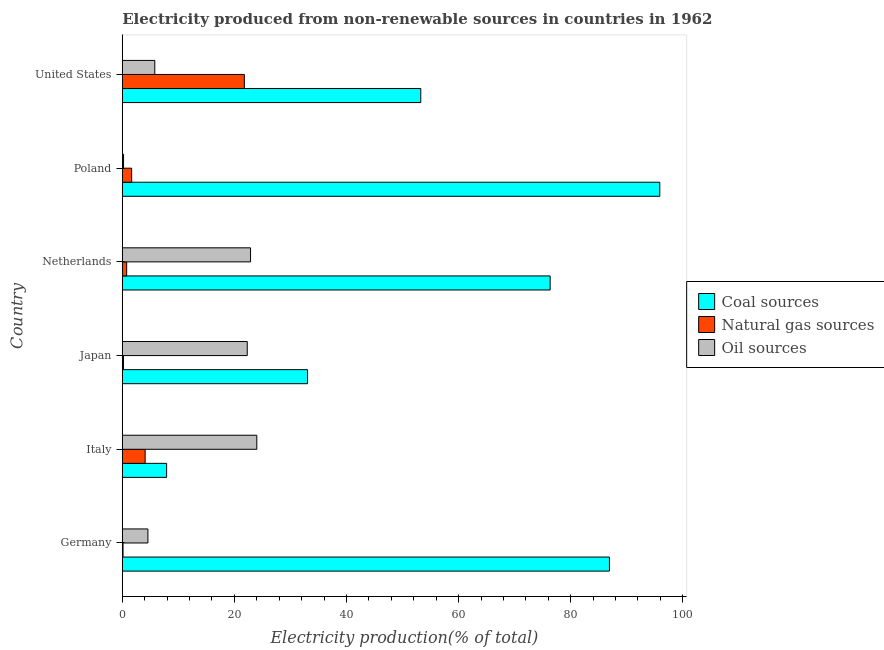Are the number of bars per tick equal to the number of legend labels?
Make the answer very short. Yes. Are the number of bars on each tick of the Y-axis equal?
Your answer should be very brief. Yes. What is the label of the 5th group of bars from the top?
Offer a terse response. Italy. In how many cases, is the number of bars for a given country not equal to the number of legend labels?
Ensure brevity in your answer.  0. What is the percentage of electricity produced by coal in Poland?
Your answer should be very brief. 95.89. Across all countries, what is the maximum percentage of electricity produced by oil sources?
Keep it short and to the point. 24. Across all countries, what is the minimum percentage of electricity produced by oil sources?
Your answer should be compact. 0.23. In which country was the percentage of electricity produced by coal minimum?
Make the answer very short. Italy. What is the total percentage of electricity produced by natural gas in the graph?
Ensure brevity in your answer.  28.66. What is the difference between the percentage of electricity produced by natural gas in Italy and that in Poland?
Your answer should be very brief. 2.41. What is the difference between the percentage of electricity produced by coal in United States and the percentage of electricity produced by oil sources in Italy?
Offer a very short reply. 29.25. What is the average percentage of electricity produced by oil sources per country?
Provide a succinct answer. 13.3. What is the difference between the percentage of electricity produced by natural gas and percentage of electricity produced by coal in Italy?
Offer a terse response. -3.83. What is the ratio of the percentage of electricity produced by coal in Germany to that in Poland?
Your response must be concise. 0.91. Is the percentage of electricity produced by coal in Germany less than that in Japan?
Make the answer very short. No. What is the difference between the highest and the second highest percentage of electricity produced by oil sources?
Offer a very short reply. 1.12. What is the difference between the highest and the lowest percentage of electricity produced by natural gas?
Keep it short and to the point. 21.64. What does the 1st bar from the top in Poland represents?
Provide a short and direct response. Oil sources. What does the 2nd bar from the bottom in Poland represents?
Offer a terse response. Natural gas sources. Is it the case that in every country, the sum of the percentage of electricity produced by coal and percentage of electricity produced by natural gas is greater than the percentage of electricity produced by oil sources?
Keep it short and to the point. No. How many countries are there in the graph?
Ensure brevity in your answer.  6. Are the values on the major ticks of X-axis written in scientific E-notation?
Offer a very short reply. No. Does the graph contain any zero values?
Your answer should be very brief. No. Where does the legend appear in the graph?
Your answer should be compact. Center right. What is the title of the graph?
Offer a very short reply. Electricity produced from non-renewable sources in countries in 1962. Does "Ages 20-60" appear as one of the legend labels in the graph?
Your answer should be very brief. No. What is the label or title of the X-axis?
Provide a short and direct response. Electricity production(% of total). What is the Electricity production(% of total) of Coal sources in Germany?
Offer a very short reply. 86.91. What is the Electricity production(% of total) in Natural gas sources in Germany?
Your response must be concise. 0.14. What is the Electricity production(% of total) in Oil sources in Germany?
Keep it short and to the point. 4.57. What is the Electricity production(% of total) of Coal sources in Italy?
Give a very brief answer. 7.91. What is the Electricity production(% of total) in Natural gas sources in Italy?
Offer a very short reply. 4.08. What is the Electricity production(% of total) of Oil sources in Italy?
Provide a succinct answer. 24. What is the Electricity production(% of total) in Coal sources in Japan?
Provide a short and direct response. 33.05. What is the Electricity production(% of total) in Natural gas sources in Japan?
Ensure brevity in your answer.  0.21. What is the Electricity production(% of total) in Oil sources in Japan?
Provide a short and direct response. 22.29. What is the Electricity production(% of total) in Coal sources in Netherlands?
Offer a very short reply. 76.33. What is the Electricity production(% of total) in Natural gas sources in Netherlands?
Your answer should be very brief. 0.78. What is the Electricity production(% of total) in Oil sources in Netherlands?
Offer a terse response. 22.88. What is the Electricity production(% of total) in Coal sources in Poland?
Your response must be concise. 95.89. What is the Electricity production(% of total) of Natural gas sources in Poland?
Keep it short and to the point. 1.67. What is the Electricity production(% of total) of Oil sources in Poland?
Make the answer very short. 0.23. What is the Electricity production(% of total) in Coal sources in United States?
Your answer should be compact. 53.25. What is the Electricity production(% of total) in Natural gas sources in United States?
Provide a short and direct response. 21.78. What is the Electricity production(% of total) in Oil sources in United States?
Your answer should be very brief. 5.8. Across all countries, what is the maximum Electricity production(% of total) of Coal sources?
Your answer should be compact. 95.89. Across all countries, what is the maximum Electricity production(% of total) of Natural gas sources?
Offer a very short reply. 21.78. Across all countries, what is the maximum Electricity production(% of total) in Oil sources?
Ensure brevity in your answer.  24. Across all countries, what is the minimum Electricity production(% of total) of Coal sources?
Your response must be concise. 7.91. Across all countries, what is the minimum Electricity production(% of total) in Natural gas sources?
Ensure brevity in your answer.  0.14. Across all countries, what is the minimum Electricity production(% of total) in Oil sources?
Provide a short and direct response. 0.23. What is the total Electricity production(% of total) in Coal sources in the graph?
Offer a terse response. 353.34. What is the total Electricity production(% of total) of Natural gas sources in the graph?
Your answer should be very brief. 28.66. What is the total Electricity production(% of total) in Oil sources in the graph?
Your response must be concise. 79.77. What is the difference between the Electricity production(% of total) of Coal sources in Germany and that in Italy?
Your answer should be very brief. 79. What is the difference between the Electricity production(% of total) in Natural gas sources in Germany and that in Italy?
Your response must be concise. -3.94. What is the difference between the Electricity production(% of total) in Oil sources in Germany and that in Italy?
Ensure brevity in your answer.  -19.43. What is the difference between the Electricity production(% of total) of Coal sources in Germany and that in Japan?
Your response must be concise. 53.86. What is the difference between the Electricity production(% of total) of Natural gas sources in Germany and that in Japan?
Provide a succinct answer. -0.08. What is the difference between the Electricity production(% of total) of Oil sources in Germany and that in Japan?
Provide a succinct answer. -17.72. What is the difference between the Electricity production(% of total) in Coal sources in Germany and that in Netherlands?
Offer a terse response. 10.58. What is the difference between the Electricity production(% of total) of Natural gas sources in Germany and that in Netherlands?
Offer a terse response. -0.65. What is the difference between the Electricity production(% of total) in Oil sources in Germany and that in Netherlands?
Keep it short and to the point. -18.31. What is the difference between the Electricity production(% of total) in Coal sources in Germany and that in Poland?
Provide a succinct answer. -8.98. What is the difference between the Electricity production(% of total) in Natural gas sources in Germany and that in Poland?
Provide a succinct answer. -1.53. What is the difference between the Electricity production(% of total) of Oil sources in Germany and that in Poland?
Your response must be concise. 4.35. What is the difference between the Electricity production(% of total) of Coal sources in Germany and that in United States?
Your answer should be very brief. 33.66. What is the difference between the Electricity production(% of total) in Natural gas sources in Germany and that in United States?
Offer a terse response. -21.64. What is the difference between the Electricity production(% of total) in Oil sources in Germany and that in United States?
Provide a short and direct response. -1.23. What is the difference between the Electricity production(% of total) in Coal sources in Italy and that in Japan?
Ensure brevity in your answer.  -25.14. What is the difference between the Electricity production(% of total) of Natural gas sources in Italy and that in Japan?
Provide a short and direct response. 3.86. What is the difference between the Electricity production(% of total) in Oil sources in Italy and that in Japan?
Your answer should be compact. 1.71. What is the difference between the Electricity production(% of total) in Coal sources in Italy and that in Netherlands?
Your answer should be very brief. -68.42. What is the difference between the Electricity production(% of total) of Natural gas sources in Italy and that in Netherlands?
Give a very brief answer. 3.29. What is the difference between the Electricity production(% of total) in Oil sources in Italy and that in Netherlands?
Provide a succinct answer. 1.12. What is the difference between the Electricity production(% of total) of Coal sources in Italy and that in Poland?
Make the answer very short. -87.98. What is the difference between the Electricity production(% of total) of Natural gas sources in Italy and that in Poland?
Ensure brevity in your answer.  2.41. What is the difference between the Electricity production(% of total) of Oil sources in Italy and that in Poland?
Give a very brief answer. 23.77. What is the difference between the Electricity production(% of total) in Coal sources in Italy and that in United States?
Your answer should be compact. -45.34. What is the difference between the Electricity production(% of total) of Natural gas sources in Italy and that in United States?
Provide a short and direct response. -17.7. What is the difference between the Electricity production(% of total) in Oil sources in Italy and that in United States?
Ensure brevity in your answer.  18.2. What is the difference between the Electricity production(% of total) in Coal sources in Japan and that in Netherlands?
Your response must be concise. -43.28. What is the difference between the Electricity production(% of total) in Natural gas sources in Japan and that in Netherlands?
Your response must be concise. -0.57. What is the difference between the Electricity production(% of total) in Oil sources in Japan and that in Netherlands?
Keep it short and to the point. -0.59. What is the difference between the Electricity production(% of total) of Coal sources in Japan and that in Poland?
Your response must be concise. -62.84. What is the difference between the Electricity production(% of total) in Natural gas sources in Japan and that in Poland?
Keep it short and to the point. -1.46. What is the difference between the Electricity production(% of total) of Oil sources in Japan and that in Poland?
Make the answer very short. 22.07. What is the difference between the Electricity production(% of total) of Coal sources in Japan and that in United States?
Your answer should be very brief. -20.2. What is the difference between the Electricity production(% of total) of Natural gas sources in Japan and that in United States?
Offer a very short reply. -21.56. What is the difference between the Electricity production(% of total) of Oil sources in Japan and that in United States?
Keep it short and to the point. 16.49. What is the difference between the Electricity production(% of total) of Coal sources in Netherlands and that in Poland?
Offer a terse response. -19.56. What is the difference between the Electricity production(% of total) in Natural gas sources in Netherlands and that in Poland?
Your answer should be very brief. -0.89. What is the difference between the Electricity production(% of total) of Oil sources in Netherlands and that in Poland?
Give a very brief answer. 22.66. What is the difference between the Electricity production(% of total) in Coal sources in Netherlands and that in United States?
Your answer should be compact. 23.08. What is the difference between the Electricity production(% of total) of Natural gas sources in Netherlands and that in United States?
Your response must be concise. -20.99. What is the difference between the Electricity production(% of total) of Oil sources in Netherlands and that in United States?
Make the answer very short. 17.08. What is the difference between the Electricity production(% of total) of Coal sources in Poland and that in United States?
Give a very brief answer. 42.64. What is the difference between the Electricity production(% of total) in Natural gas sources in Poland and that in United States?
Provide a succinct answer. -20.11. What is the difference between the Electricity production(% of total) of Oil sources in Poland and that in United States?
Provide a short and direct response. -5.57. What is the difference between the Electricity production(% of total) of Coal sources in Germany and the Electricity production(% of total) of Natural gas sources in Italy?
Your answer should be very brief. 82.83. What is the difference between the Electricity production(% of total) in Coal sources in Germany and the Electricity production(% of total) in Oil sources in Italy?
Your response must be concise. 62.91. What is the difference between the Electricity production(% of total) in Natural gas sources in Germany and the Electricity production(% of total) in Oil sources in Italy?
Your answer should be very brief. -23.86. What is the difference between the Electricity production(% of total) of Coal sources in Germany and the Electricity production(% of total) of Natural gas sources in Japan?
Ensure brevity in your answer.  86.7. What is the difference between the Electricity production(% of total) in Coal sources in Germany and the Electricity production(% of total) in Oil sources in Japan?
Offer a terse response. 64.62. What is the difference between the Electricity production(% of total) in Natural gas sources in Germany and the Electricity production(% of total) in Oil sources in Japan?
Your answer should be very brief. -22.16. What is the difference between the Electricity production(% of total) of Coal sources in Germany and the Electricity production(% of total) of Natural gas sources in Netherlands?
Offer a terse response. 86.12. What is the difference between the Electricity production(% of total) in Coal sources in Germany and the Electricity production(% of total) in Oil sources in Netherlands?
Offer a terse response. 64.03. What is the difference between the Electricity production(% of total) in Natural gas sources in Germany and the Electricity production(% of total) in Oil sources in Netherlands?
Provide a short and direct response. -22.75. What is the difference between the Electricity production(% of total) in Coal sources in Germany and the Electricity production(% of total) in Natural gas sources in Poland?
Your answer should be very brief. 85.24. What is the difference between the Electricity production(% of total) of Coal sources in Germany and the Electricity production(% of total) of Oil sources in Poland?
Your response must be concise. 86.68. What is the difference between the Electricity production(% of total) in Natural gas sources in Germany and the Electricity production(% of total) in Oil sources in Poland?
Give a very brief answer. -0.09. What is the difference between the Electricity production(% of total) in Coal sources in Germany and the Electricity production(% of total) in Natural gas sources in United States?
Provide a short and direct response. 65.13. What is the difference between the Electricity production(% of total) in Coal sources in Germany and the Electricity production(% of total) in Oil sources in United States?
Give a very brief answer. 81.11. What is the difference between the Electricity production(% of total) in Natural gas sources in Germany and the Electricity production(% of total) in Oil sources in United States?
Provide a succinct answer. -5.66. What is the difference between the Electricity production(% of total) in Coal sources in Italy and the Electricity production(% of total) in Natural gas sources in Japan?
Keep it short and to the point. 7.7. What is the difference between the Electricity production(% of total) of Coal sources in Italy and the Electricity production(% of total) of Oil sources in Japan?
Your response must be concise. -14.38. What is the difference between the Electricity production(% of total) in Natural gas sources in Italy and the Electricity production(% of total) in Oil sources in Japan?
Make the answer very short. -18.21. What is the difference between the Electricity production(% of total) of Coal sources in Italy and the Electricity production(% of total) of Natural gas sources in Netherlands?
Offer a very short reply. 7.12. What is the difference between the Electricity production(% of total) of Coal sources in Italy and the Electricity production(% of total) of Oil sources in Netherlands?
Make the answer very short. -14.97. What is the difference between the Electricity production(% of total) of Natural gas sources in Italy and the Electricity production(% of total) of Oil sources in Netherlands?
Offer a terse response. -18.8. What is the difference between the Electricity production(% of total) of Coal sources in Italy and the Electricity production(% of total) of Natural gas sources in Poland?
Make the answer very short. 6.24. What is the difference between the Electricity production(% of total) in Coal sources in Italy and the Electricity production(% of total) in Oil sources in Poland?
Your answer should be compact. 7.68. What is the difference between the Electricity production(% of total) of Natural gas sources in Italy and the Electricity production(% of total) of Oil sources in Poland?
Your answer should be compact. 3.85. What is the difference between the Electricity production(% of total) of Coal sources in Italy and the Electricity production(% of total) of Natural gas sources in United States?
Ensure brevity in your answer.  -13.87. What is the difference between the Electricity production(% of total) of Coal sources in Italy and the Electricity production(% of total) of Oil sources in United States?
Provide a short and direct response. 2.11. What is the difference between the Electricity production(% of total) of Natural gas sources in Italy and the Electricity production(% of total) of Oil sources in United States?
Give a very brief answer. -1.72. What is the difference between the Electricity production(% of total) of Coal sources in Japan and the Electricity production(% of total) of Natural gas sources in Netherlands?
Provide a succinct answer. 32.26. What is the difference between the Electricity production(% of total) in Coal sources in Japan and the Electricity production(% of total) in Oil sources in Netherlands?
Your response must be concise. 10.17. What is the difference between the Electricity production(% of total) of Natural gas sources in Japan and the Electricity production(% of total) of Oil sources in Netherlands?
Offer a very short reply. -22.67. What is the difference between the Electricity production(% of total) in Coal sources in Japan and the Electricity production(% of total) in Natural gas sources in Poland?
Make the answer very short. 31.38. What is the difference between the Electricity production(% of total) in Coal sources in Japan and the Electricity production(% of total) in Oil sources in Poland?
Ensure brevity in your answer.  32.82. What is the difference between the Electricity production(% of total) of Natural gas sources in Japan and the Electricity production(% of total) of Oil sources in Poland?
Make the answer very short. -0.01. What is the difference between the Electricity production(% of total) in Coal sources in Japan and the Electricity production(% of total) in Natural gas sources in United States?
Your answer should be compact. 11.27. What is the difference between the Electricity production(% of total) of Coal sources in Japan and the Electricity production(% of total) of Oil sources in United States?
Keep it short and to the point. 27.25. What is the difference between the Electricity production(% of total) in Natural gas sources in Japan and the Electricity production(% of total) in Oil sources in United States?
Your response must be concise. -5.59. What is the difference between the Electricity production(% of total) in Coal sources in Netherlands and the Electricity production(% of total) in Natural gas sources in Poland?
Offer a terse response. 74.66. What is the difference between the Electricity production(% of total) of Coal sources in Netherlands and the Electricity production(% of total) of Oil sources in Poland?
Your answer should be compact. 76.11. What is the difference between the Electricity production(% of total) in Natural gas sources in Netherlands and the Electricity production(% of total) in Oil sources in Poland?
Keep it short and to the point. 0.56. What is the difference between the Electricity production(% of total) in Coal sources in Netherlands and the Electricity production(% of total) in Natural gas sources in United States?
Offer a terse response. 54.56. What is the difference between the Electricity production(% of total) in Coal sources in Netherlands and the Electricity production(% of total) in Oil sources in United States?
Make the answer very short. 70.53. What is the difference between the Electricity production(% of total) of Natural gas sources in Netherlands and the Electricity production(% of total) of Oil sources in United States?
Provide a short and direct response. -5.02. What is the difference between the Electricity production(% of total) in Coal sources in Poland and the Electricity production(% of total) in Natural gas sources in United States?
Keep it short and to the point. 74.11. What is the difference between the Electricity production(% of total) of Coal sources in Poland and the Electricity production(% of total) of Oil sources in United States?
Your answer should be compact. 90.09. What is the difference between the Electricity production(% of total) of Natural gas sources in Poland and the Electricity production(% of total) of Oil sources in United States?
Your answer should be compact. -4.13. What is the average Electricity production(% of total) of Coal sources per country?
Your response must be concise. 58.89. What is the average Electricity production(% of total) of Natural gas sources per country?
Provide a succinct answer. 4.78. What is the average Electricity production(% of total) of Oil sources per country?
Ensure brevity in your answer.  13.3. What is the difference between the Electricity production(% of total) in Coal sources and Electricity production(% of total) in Natural gas sources in Germany?
Your answer should be compact. 86.77. What is the difference between the Electricity production(% of total) in Coal sources and Electricity production(% of total) in Oil sources in Germany?
Your answer should be compact. 82.34. What is the difference between the Electricity production(% of total) of Natural gas sources and Electricity production(% of total) of Oil sources in Germany?
Make the answer very short. -4.44. What is the difference between the Electricity production(% of total) in Coal sources and Electricity production(% of total) in Natural gas sources in Italy?
Offer a terse response. 3.83. What is the difference between the Electricity production(% of total) of Coal sources and Electricity production(% of total) of Oil sources in Italy?
Your answer should be compact. -16.09. What is the difference between the Electricity production(% of total) in Natural gas sources and Electricity production(% of total) in Oil sources in Italy?
Make the answer very short. -19.92. What is the difference between the Electricity production(% of total) in Coal sources and Electricity production(% of total) in Natural gas sources in Japan?
Ensure brevity in your answer.  32.83. What is the difference between the Electricity production(% of total) of Coal sources and Electricity production(% of total) of Oil sources in Japan?
Offer a very short reply. 10.76. What is the difference between the Electricity production(% of total) of Natural gas sources and Electricity production(% of total) of Oil sources in Japan?
Provide a succinct answer. -22.08. What is the difference between the Electricity production(% of total) of Coal sources and Electricity production(% of total) of Natural gas sources in Netherlands?
Give a very brief answer. 75.55. What is the difference between the Electricity production(% of total) of Coal sources and Electricity production(% of total) of Oil sources in Netherlands?
Your answer should be very brief. 53.45. What is the difference between the Electricity production(% of total) in Natural gas sources and Electricity production(% of total) in Oil sources in Netherlands?
Offer a very short reply. -22.1. What is the difference between the Electricity production(% of total) in Coal sources and Electricity production(% of total) in Natural gas sources in Poland?
Ensure brevity in your answer.  94.22. What is the difference between the Electricity production(% of total) of Coal sources and Electricity production(% of total) of Oil sources in Poland?
Provide a short and direct response. 95.66. What is the difference between the Electricity production(% of total) in Natural gas sources and Electricity production(% of total) in Oil sources in Poland?
Provide a short and direct response. 1.45. What is the difference between the Electricity production(% of total) in Coal sources and Electricity production(% of total) in Natural gas sources in United States?
Give a very brief answer. 31.47. What is the difference between the Electricity production(% of total) in Coal sources and Electricity production(% of total) in Oil sources in United States?
Provide a short and direct response. 47.45. What is the difference between the Electricity production(% of total) of Natural gas sources and Electricity production(% of total) of Oil sources in United States?
Ensure brevity in your answer.  15.98. What is the ratio of the Electricity production(% of total) in Coal sources in Germany to that in Italy?
Provide a succinct answer. 10.99. What is the ratio of the Electricity production(% of total) of Natural gas sources in Germany to that in Italy?
Keep it short and to the point. 0.03. What is the ratio of the Electricity production(% of total) in Oil sources in Germany to that in Italy?
Make the answer very short. 0.19. What is the ratio of the Electricity production(% of total) of Coal sources in Germany to that in Japan?
Your response must be concise. 2.63. What is the ratio of the Electricity production(% of total) in Natural gas sources in Germany to that in Japan?
Provide a succinct answer. 0.64. What is the ratio of the Electricity production(% of total) of Oil sources in Germany to that in Japan?
Ensure brevity in your answer.  0.21. What is the ratio of the Electricity production(% of total) in Coal sources in Germany to that in Netherlands?
Keep it short and to the point. 1.14. What is the ratio of the Electricity production(% of total) of Natural gas sources in Germany to that in Netherlands?
Offer a very short reply. 0.17. What is the ratio of the Electricity production(% of total) of Oil sources in Germany to that in Netherlands?
Your answer should be compact. 0.2. What is the ratio of the Electricity production(% of total) in Coal sources in Germany to that in Poland?
Your answer should be compact. 0.91. What is the ratio of the Electricity production(% of total) of Natural gas sources in Germany to that in Poland?
Your answer should be compact. 0.08. What is the ratio of the Electricity production(% of total) in Oil sources in Germany to that in Poland?
Your response must be concise. 20.21. What is the ratio of the Electricity production(% of total) of Coal sources in Germany to that in United States?
Keep it short and to the point. 1.63. What is the ratio of the Electricity production(% of total) in Natural gas sources in Germany to that in United States?
Offer a terse response. 0.01. What is the ratio of the Electricity production(% of total) in Oil sources in Germany to that in United States?
Make the answer very short. 0.79. What is the ratio of the Electricity production(% of total) of Coal sources in Italy to that in Japan?
Your response must be concise. 0.24. What is the ratio of the Electricity production(% of total) in Natural gas sources in Italy to that in Japan?
Give a very brief answer. 19.09. What is the ratio of the Electricity production(% of total) of Oil sources in Italy to that in Japan?
Your answer should be compact. 1.08. What is the ratio of the Electricity production(% of total) in Coal sources in Italy to that in Netherlands?
Ensure brevity in your answer.  0.1. What is the ratio of the Electricity production(% of total) in Natural gas sources in Italy to that in Netherlands?
Keep it short and to the point. 5.2. What is the ratio of the Electricity production(% of total) of Oil sources in Italy to that in Netherlands?
Provide a succinct answer. 1.05. What is the ratio of the Electricity production(% of total) of Coal sources in Italy to that in Poland?
Your answer should be very brief. 0.08. What is the ratio of the Electricity production(% of total) in Natural gas sources in Italy to that in Poland?
Keep it short and to the point. 2.44. What is the ratio of the Electricity production(% of total) in Oil sources in Italy to that in Poland?
Make the answer very short. 106.09. What is the ratio of the Electricity production(% of total) of Coal sources in Italy to that in United States?
Offer a very short reply. 0.15. What is the ratio of the Electricity production(% of total) in Natural gas sources in Italy to that in United States?
Your answer should be compact. 0.19. What is the ratio of the Electricity production(% of total) of Oil sources in Italy to that in United States?
Offer a terse response. 4.14. What is the ratio of the Electricity production(% of total) in Coal sources in Japan to that in Netherlands?
Offer a terse response. 0.43. What is the ratio of the Electricity production(% of total) in Natural gas sources in Japan to that in Netherlands?
Offer a terse response. 0.27. What is the ratio of the Electricity production(% of total) of Oil sources in Japan to that in Netherlands?
Offer a terse response. 0.97. What is the ratio of the Electricity production(% of total) of Coal sources in Japan to that in Poland?
Ensure brevity in your answer.  0.34. What is the ratio of the Electricity production(% of total) in Natural gas sources in Japan to that in Poland?
Provide a short and direct response. 0.13. What is the ratio of the Electricity production(% of total) in Oil sources in Japan to that in Poland?
Ensure brevity in your answer.  98.55. What is the ratio of the Electricity production(% of total) of Coal sources in Japan to that in United States?
Provide a succinct answer. 0.62. What is the ratio of the Electricity production(% of total) in Natural gas sources in Japan to that in United States?
Provide a short and direct response. 0.01. What is the ratio of the Electricity production(% of total) of Oil sources in Japan to that in United States?
Provide a succinct answer. 3.84. What is the ratio of the Electricity production(% of total) of Coal sources in Netherlands to that in Poland?
Provide a short and direct response. 0.8. What is the ratio of the Electricity production(% of total) of Natural gas sources in Netherlands to that in Poland?
Give a very brief answer. 0.47. What is the ratio of the Electricity production(% of total) in Oil sources in Netherlands to that in Poland?
Your answer should be very brief. 101.15. What is the ratio of the Electricity production(% of total) in Coal sources in Netherlands to that in United States?
Ensure brevity in your answer.  1.43. What is the ratio of the Electricity production(% of total) of Natural gas sources in Netherlands to that in United States?
Make the answer very short. 0.04. What is the ratio of the Electricity production(% of total) of Oil sources in Netherlands to that in United States?
Keep it short and to the point. 3.95. What is the ratio of the Electricity production(% of total) of Coal sources in Poland to that in United States?
Keep it short and to the point. 1.8. What is the ratio of the Electricity production(% of total) of Natural gas sources in Poland to that in United States?
Offer a terse response. 0.08. What is the ratio of the Electricity production(% of total) in Oil sources in Poland to that in United States?
Ensure brevity in your answer.  0.04. What is the difference between the highest and the second highest Electricity production(% of total) in Coal sources?
Make the answer very short. 8.98. What is the difference between the highest and the second highest Electricity production(% of total) of Natural gas sources?
Provide a short and direct response. 17.7. What is the difference between the highest and the second highest Electricity production(% of total) in Oil sources?
Your answer should be very brief. 1.12. What is the difference between the highest and the lowest Electricity production(% of total) in Coal sources?
Offer a terse response. 87.98. What is the difference between the highest and the lowest Electricity production(% of total) of Natural gas sources?
Make the answer very short. 21.64. What is the difference between the highest and the lowest Electricity production(% of total) in Oil sources?
Your response must be concise. 23.77. 